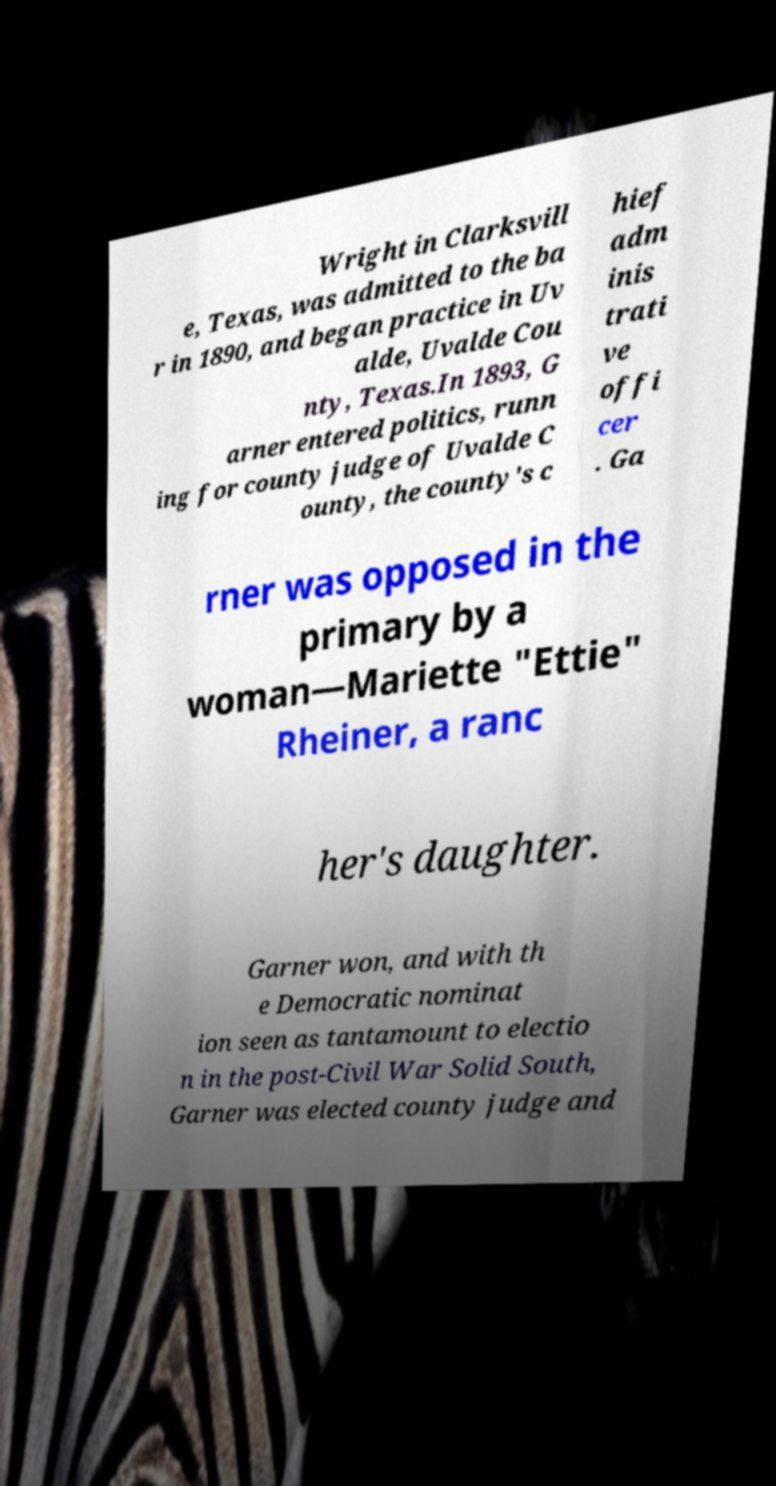Could you extract and type out the text from this image? Wright in Clarksvill e, Texas, was admitted to the ba r in 1890, and began practice in Uv alde, Uvalde Cou nty, Texas.In 1893, G arner entered politics, runn ing for county judge of Uvalde C ounty, the county's c hief adm inis trati ve offi cer . Ga rner was opposed in the primary by a woman—Mariette "Ettie" Rheiner, a ranc her's daughter. Garner won, and with th e Democratic nominat ion seen as tantamount to electio n in the post-Civil War Solid South, Garner was elected county judge and 